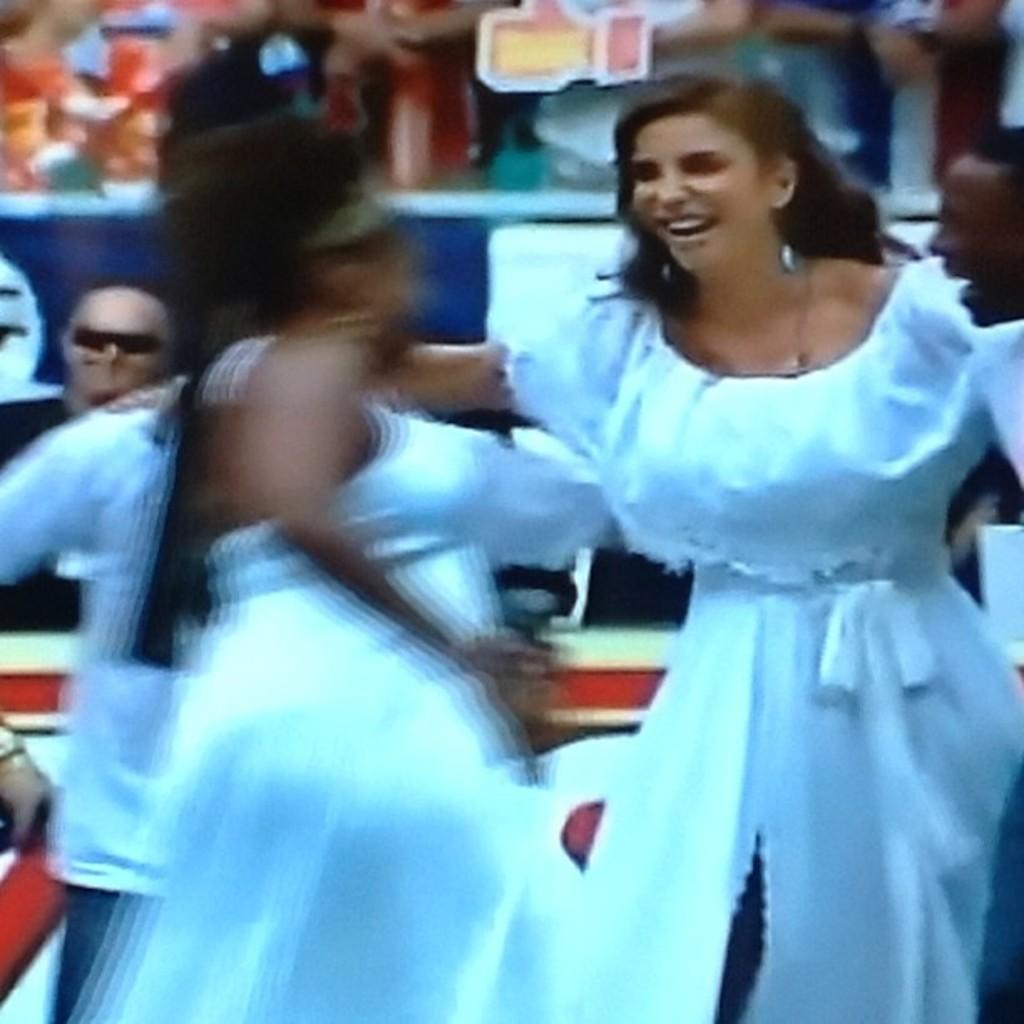Please provide a concise description of this image. In this image we can see few people. In the background it is blur. 